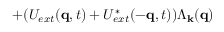<formula> <loc_0><loc_0><loc_500><loc_500>+ ( U _ { e x t } ( { q } , t ) + U _ { e x t } ^ { * } ( - { q } , t ) ) \Lambda _ { k } ( { q } )</formula> 